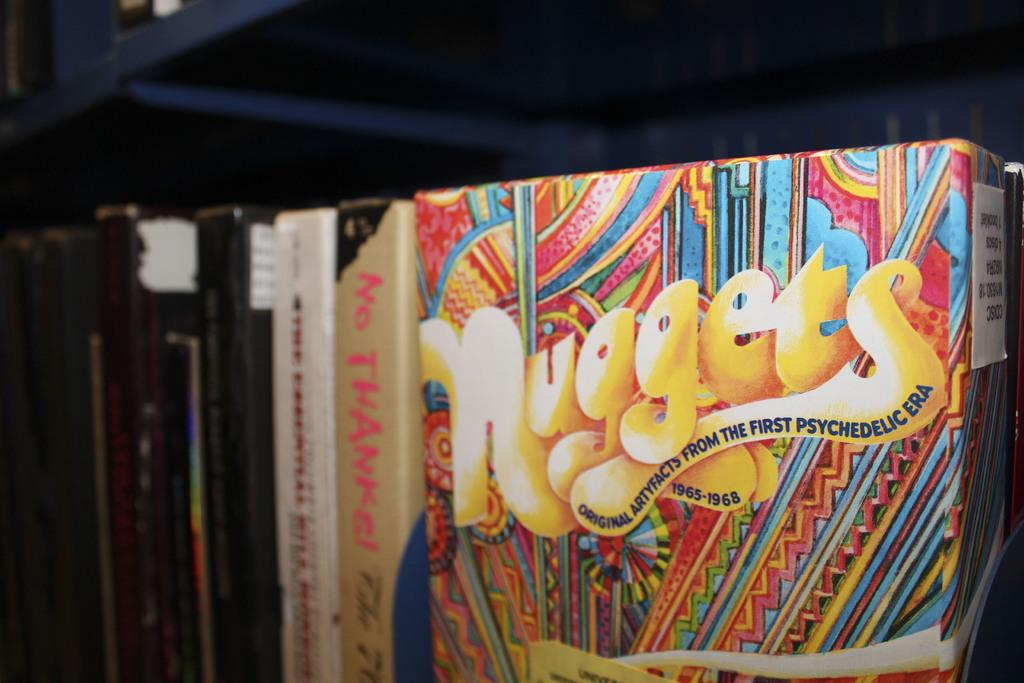Provide a one-sentence caption for the provided image. A package of Nuggets from the psychedelic era covers the years 1965 through 1968. 